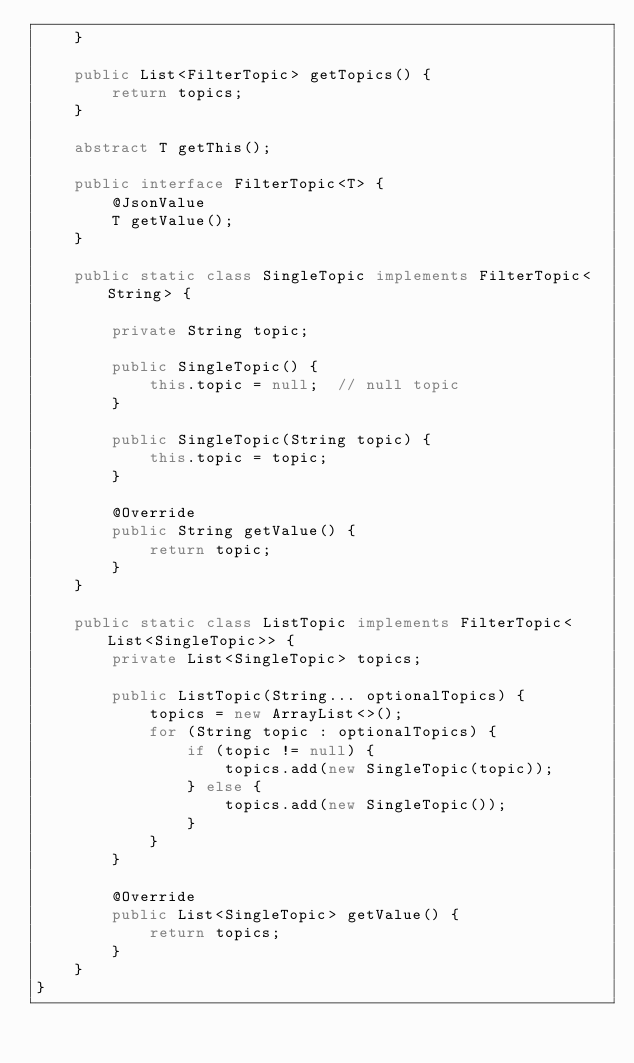Convert code to text. <code><loc_0><loc_0><loc_500><loc_500><_Java_>    }

    public List<FilterTopic> getTopics() {
        return topics;
    }

    abstract T getThis();

    public interface FilterTopic<T> {
        @JsonValue
        T getValue();
    }

    public static class SingleTopic implements FilterTopic<String> {

        private String topic;

        public SingleTopic() {
            this.topic = null;  // null topic
        }

        public SingleTopic(String topic) {
            this.topic = topic;
        }

        @Override
        public String getValue() {
            return topic;
        }
    }

    public static class ListTopic implements FilterTopic<List<SingleTopic>> {
        private List<SingleTopic> topics;

        public ListTopic(String... optionalTopics) {
            topics = new ArrayList<>();
            for (String topic : optionalTopics) {
                if (topic != null) {
                    topics.add(new SingleTopic(topic));
                } else {
                    topics.add(new SingleTopic());
                }
            }
        }

        @Override
        public List<SingleTopic> getValue() {
            return topics;
        }
    }
}
</code> 